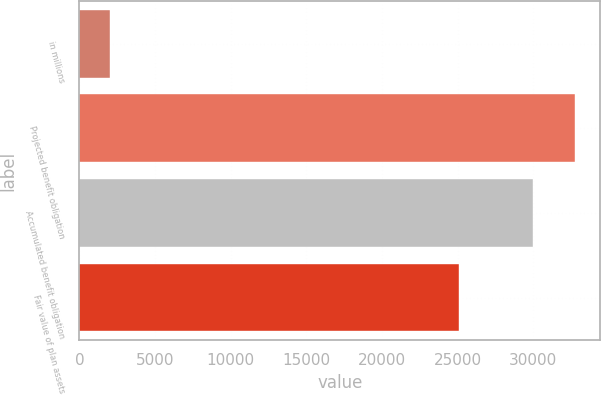Convert chart to OTSL. <chart><loc_0><loc_0><loc_500><loc_500><bar_chart><fcel>in millions<fcel>Projected benefit obligation<fcel>Accumulated benefit obligation<fcel>Fair value of plan assets<nl><fcel>2018<fcel>32785.1<fcel>29961<fcel>25101<nl></chart> 